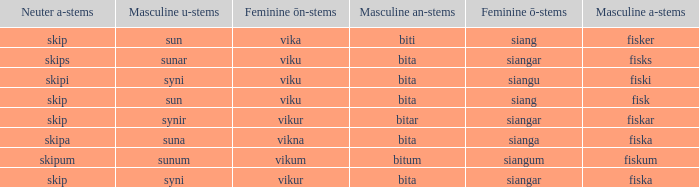What is the masculine an form for the word with a feminine ö ending of siangar and a masculine u ending of sunar? Bita. Give me the full table as a dictionary. {'header': ['Neuter a-stems', 'Masculine u-stems', 'Feminine ōn-stems', 'Masculine an-stems', 'Feminine ō-stems', 'Masculine a-stems'], 'rows': [['skip', 'sun', 'vika', 'biti', 'siang', 'fisker'], ['skips', 'sunar', 'viku', 'bita', 'siangar', 'fisks'], ['skipi', 'syni', 'viku', 'bita', 'siangu', 'fiski'], ['skip', 'sun', 'viku', 'bita', 'siang', 'fisk'], ['skip', 'synir', 'vikur', 'bitar', 'siangar', 'fiskar'], ['skipa', 'suna', 'vikna', 'bita', 'sianga', 'fiska'], ['skipum', 'sunum', 'vikum', 'bitum', 'siangum', 'fiskum'], ['skip', 'syni', 'vikur', 'bita', 'siangar', 'fiska']]} 